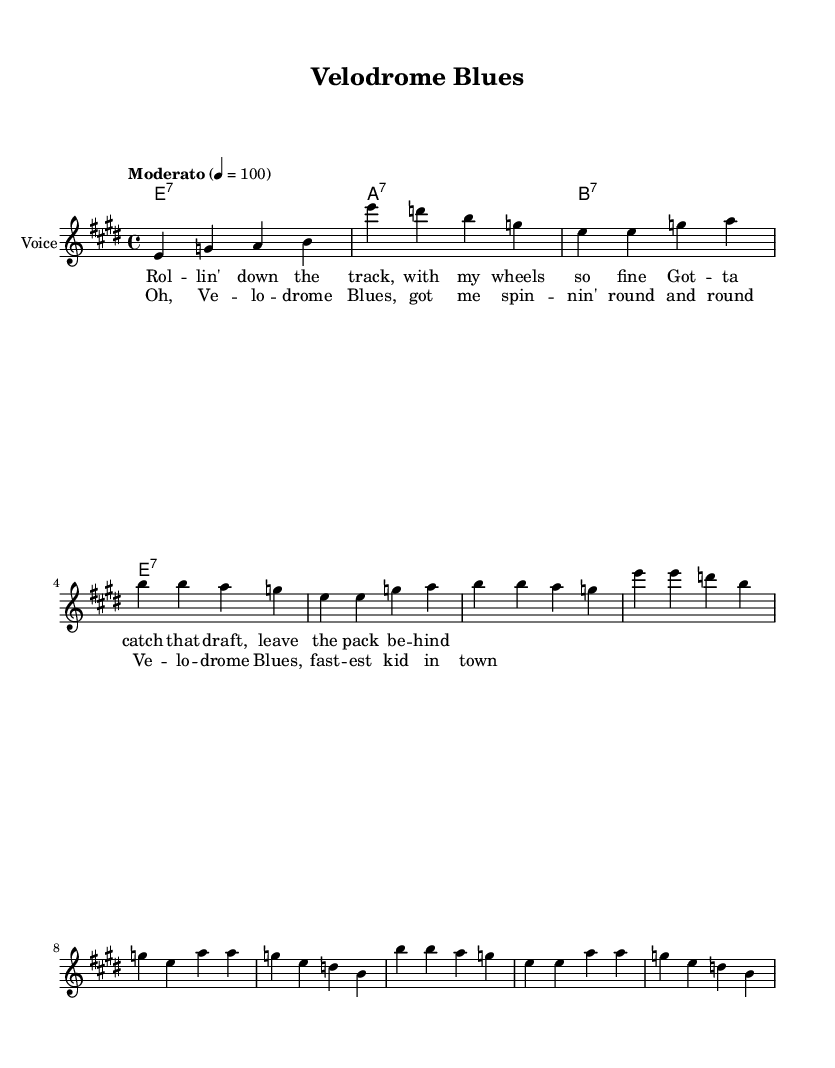What is the key signature of this music? The key signature is E major, which has four sharps (F#, C#, G#, and D#). This can be identified at the beginning of the score, where the key signature is notated.
Answer: E major What is the time signature of this music? The time signature is 4/4, which indicates that there are four beats in a measure and a quarter note receives one beat. This can be found directly under the clef symbol in the sheet music.
Answer: 4/4 What is the tempo marking for this piece? The tempo marking is "Moderato," which indicates a moderate speed for the performance of the piece. This is noted above the staff, indicating how quickly the music should be played.
Answer: Moderato How many measures are in the verse section? The verse section consists of two measures, as indicated by the series of notes and rests that fit into the staff within a specified timeframe. Upon counting the bars visually, only two distinct measures are present for the verse.
Answer: 2 What type of chords are used in the harmonies? The chords used in the harmonies are dominant seventh chords, as denoted by the notation (e1:7, a1:7, b1:7) next to each measure of the harmonies in the score. This signifies that each chord is a seventh chord built off the root note.
Answer: Seventh What is the main theme of the lyrics in the chorus? The main theme of the lyrics in the chorus revolves around cycling in a velodrome and feeling like the best or fastest cyclist ("fastest kid in town"). By inspecting the text of the chorus section, the focus on the sport is clear.
Answer: Cycling Which musical genre does this piece belong to? This piece belongs to the Blues genre, which can be identified by the structure of the lyrics and the chord progression featuring seventh chords, typical of Blues music. The title "Velodrome Blues" also reaffirms this classification.
Answer: Blues 